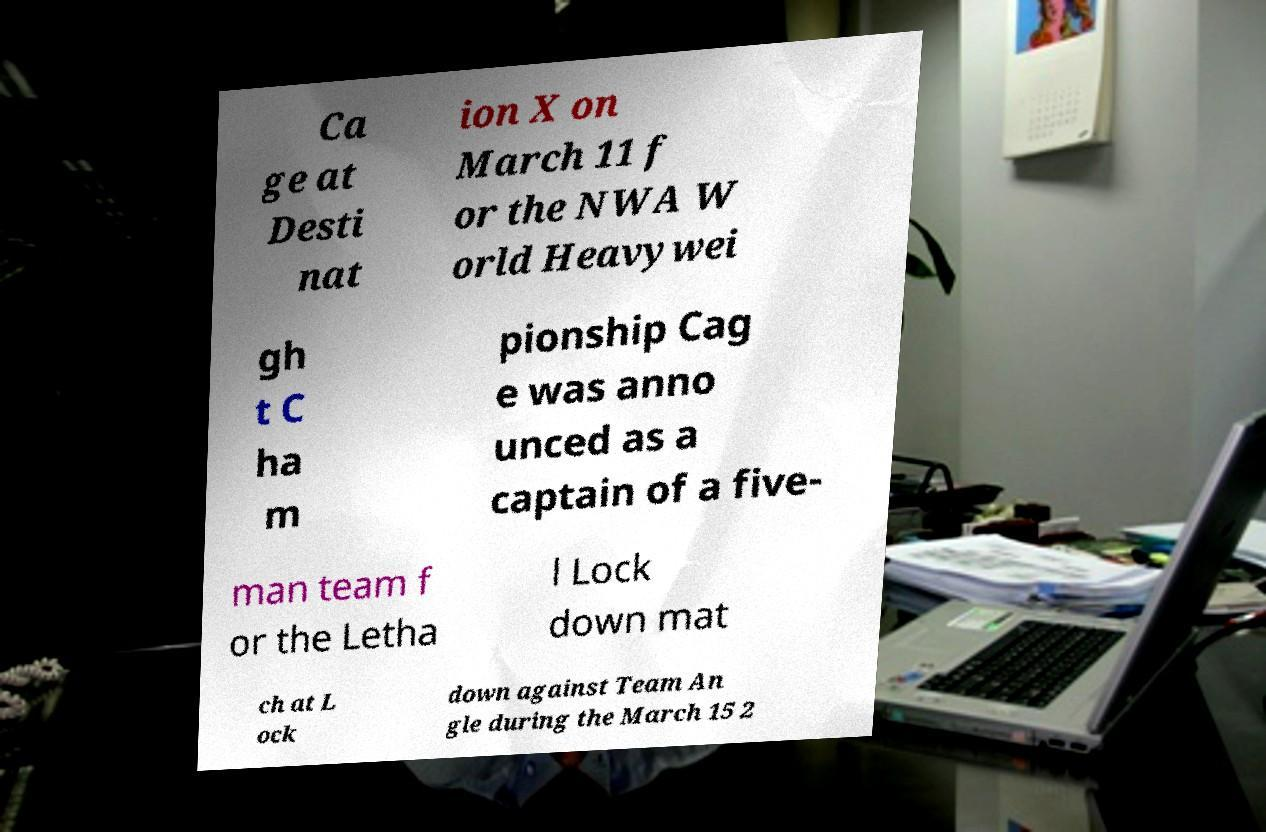For documentation purposes, I need the text within this image transcribed. Could you provide that? Ca ge at Desti nat ion X on March 11 f or the NWA W orld Heavywei gh t C ha m pionship Cag e was anno unced as a captain of a five- man team f or the Letha l Lock down mat ch at L ock down against Team An gle during the March 15 2 